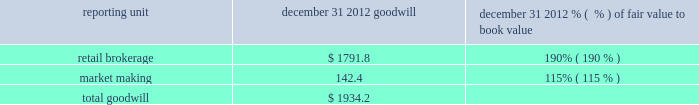There is no goodwill assigned to reporting units within the balance sheet management segment .
The table shows the amount of goodwill allocated to each of the reporting units and the fair value as a percentage of book value for the reporting units in the trading and investing segment ( dollars in millions ) : .
We also evaluate the remaining useful lives on intangible assets each reporting period to determine whether events and circumstances warrant a revision to the remaining period of amortization .
Other intangible assets have a weighted average remaining useful life of 13 years .
We did not recognize impairment on our other intangible assets in the periods presented .
Effects if actual results differ if our estimates of fair value for the reporting units change due to changes in our business or other factors , we may determine that an impairment charge is necessary .
Estimates of fair value are determined based on a complex model using estimated future cash flows and company comparisons .
If actual cash flows are less than estimated future cash flows used in the annual assessment , then goodwill would have to be tested for impairment .
The estimated fair value of the market making reporting unit as a percentage of book value was approximately 115% ( 115 % ) ; therefore , if actual cash flows are less than our estimated cash flows , goodwill impairment could occur in the market making reporting unit in the future .
These cash flows will be monitored closely to determine if a further evaluation of potential impairment is necessary so that impairment could be recognized in a timely manner .
In addition , following the review of order handling practices and pricing for order flow between e*trade securities llc and gi execution services , llc , our regulators may initiate investigations into our historical practices which could subject us to monetary penalties and cease-and-desist orders , which could also prompt claims by customers of e*trade securities llc .
Any of these actions could materially and adversely affect our market making and trade execution businesses , which could impact future cash flows and could result in goodwill impairment .
Intangible assets are amortized over their estimated useful lives .
If changes in the estimated underlying revenue occur , impairment or a change in the remaining life may need to be recognized .
Estimates of effective tax rates , deferred taxes and valuation allowance description in preparing the consolidated financial statements , we calculate income tax expense ( benefit ) based on our interpretation of the tax laws in the various jurisdictions where we conduct business .
This requires us to estimate current tax obligations and the realizability of uncertain tax positions and to assess temporary differences between the financial statement carrying amounts and the tax basis of assets and liabilities .
These differences result in deferred tax assets and liabilities , the net amount of which we show as other assets or other liabilities on the consolidated balance sheet .
We must also assess the likelihood that each of the deferred tax assets will be realized .
To the extent we believe that realization is not more likely than not , we establish a valuation allowance .
When we establish a valuation allowance or increase this allowance in a reporting period , we generally record a corresponding tax expense in the consolidated statement of income ( loss ) .
Conversely , to the extent circumstances indicate that a valuation allowance is no longer necessary , that portion of the valuation allowance is reversed , which generally reduces overall income tax expense .
At december 31 , 2012 we had net deferred tax assets of $ 1416.2 million , net of a valuation allowance ( on state , foreign country and charitable contribution deferred tax assets ) of $ 97.8 million. .
What percentage of total goodwill is comprised of retail brokerage at december 31 2012? 
Computations: (1791.8 / 1934.2)
Answer: 0.92638. 